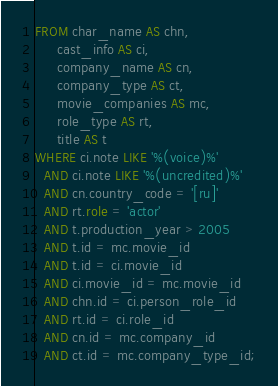Convert code to text. <code><loc_0><loc_0><loc_500><loc_500><_SQL_>FROM char_name AS chn,
     cast_info AS ci,
     company_name AS cn,
     company_type AS ct,
     movie_companies AS mc,
     role_type AS rt,
     title AS t
WHERE ci.note LIKE '%(voice)%'
  AND ci.note LIKE '%(uncredited)%'
  AND cn.country_code = '[ru]'
  AND rt.role = 'actor'
  AND t.production_year > 2005
  AND t.id = mc.movie_id
  AND t.id = ci.movie_id
  AND ci.movie_id = mc.movie_id
  AND chn.id = ci.person_role_id
  AND rt.id = ci.role_id
  AND cn.id = mc.company_id
  AND ct.id = mc.company_type_id;

</code> 